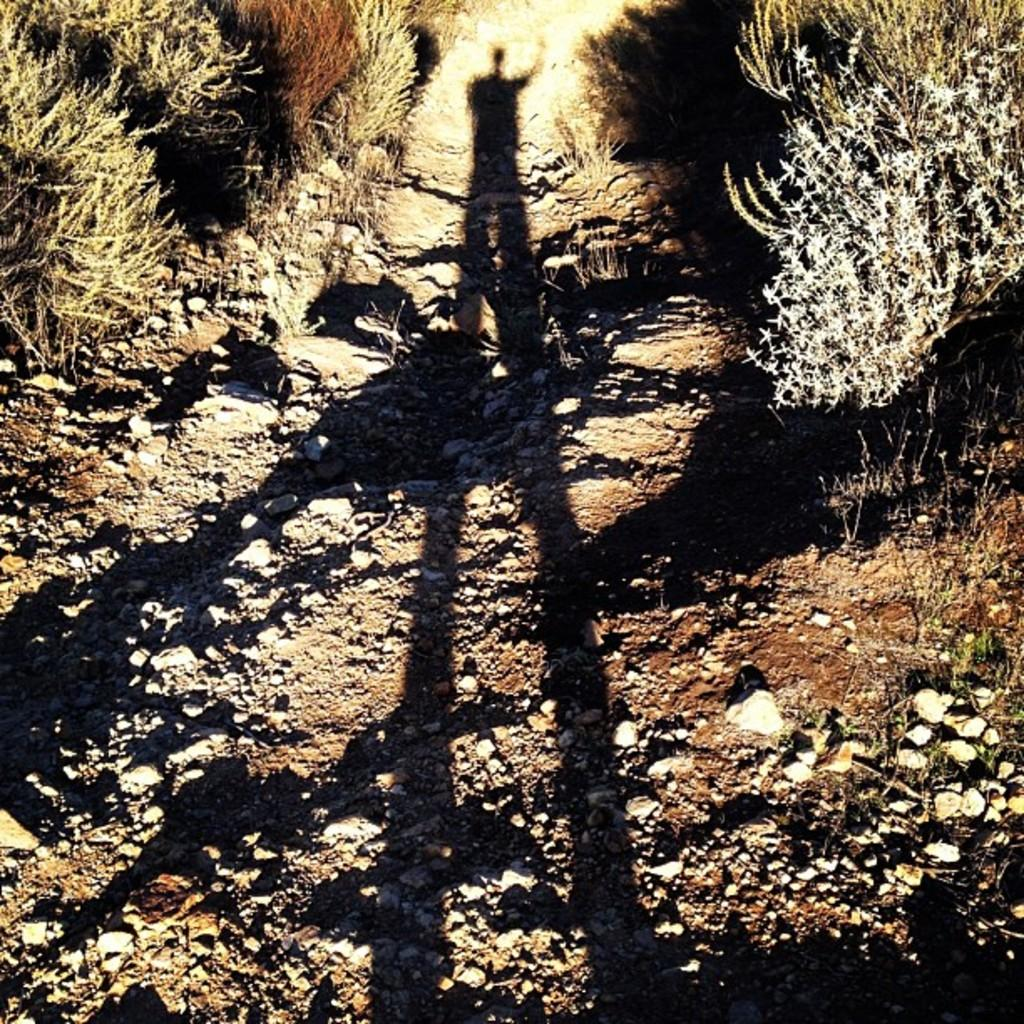What type of terrain is depicted in the image? There is sand in the image. What other elements can be seen in the terrain? There are stones and plants in the image. Can you describe any other features in the image? There is a shadow in the image. What type of bird can be seen swimming in the sand in the image? There is no bird present in the image, and the sand is not depicted as a body of water for swimming. 